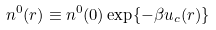Convert formula to latex. <formula><loc_0><loc_0><loc_500><loc_500>n ^ { 0 } ( r ) \equiv n ^ { 0 } ( 0 ) \exp \{ - \beta u _ { c } ( r ) \}</formula> 